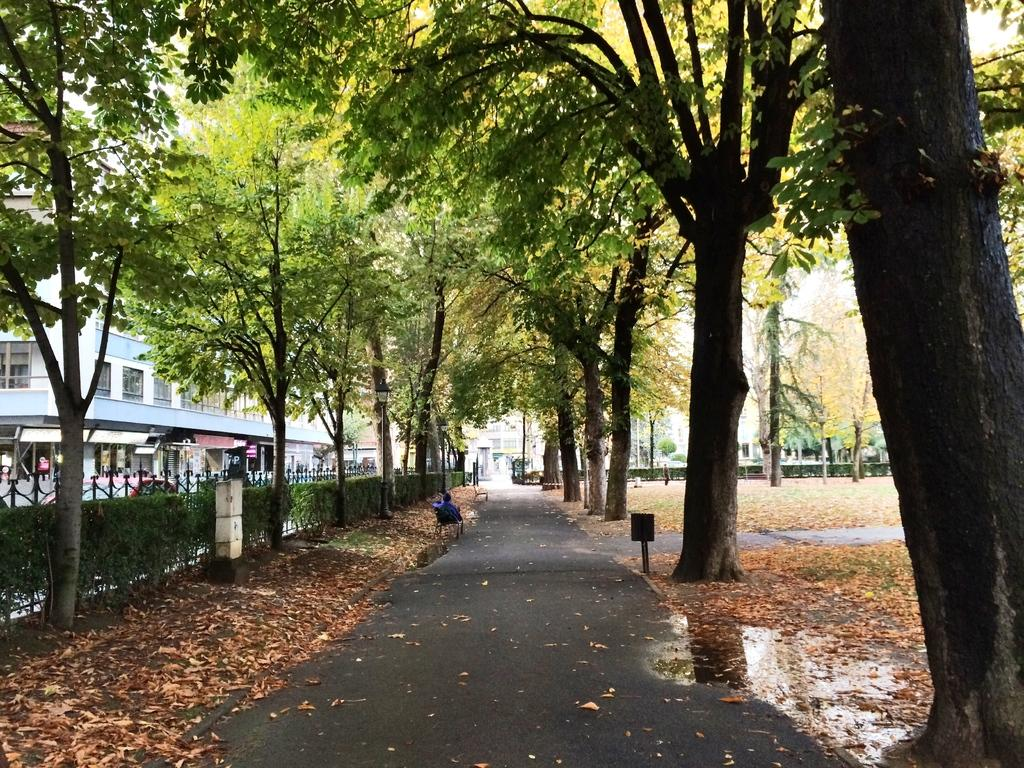What type of vegetation can be seen in the image? There are many trees and plants in the image. What objects are present for cooking or barbecuing? There are grills in the image. What structure can be seen in the background? There is a building visible in the background. What pathway is available for walking in the image? There is a walkway at the bottom of the image. What is the person in the image doing? The presence of a person is mentioned, but their activity is not specified in the provided facts. What additional detail can be observed on the ground? Dry leaves are visible in the image. Can you see a giraffe walking on the walkway in the image? There is no giraffe present in the image; it features trees, plants, grills, a building, a walkway, dry leaves, and a person. What type of punishment is being administered to the person in the image? There is no indication of any punishment being administered in the image; the person's activity is not specified. 